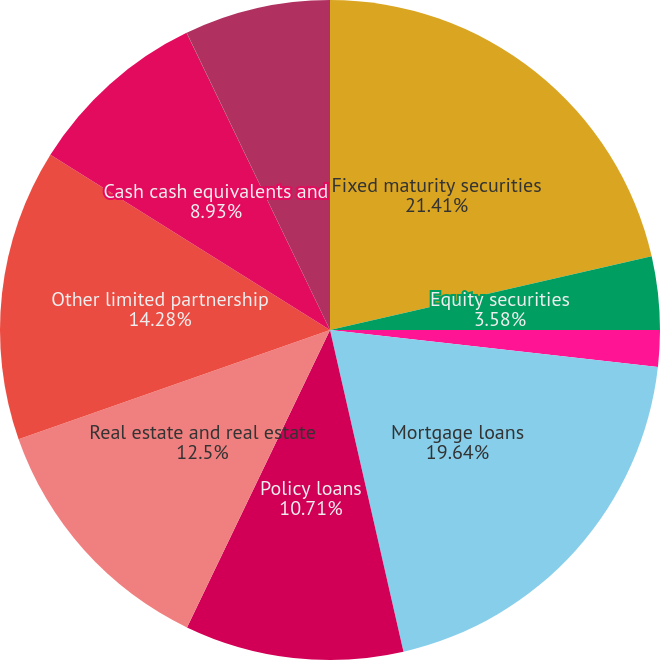Convert chart. <chart><loc_0><loc_0><loc_500><loc_500><pie_chart><fcel>Fixed maturity securities<fcel>Equity securities<fcel>FVO and trading securities<fcel>Mortgage loans<fcel>Policy loans<fcel>Real estate and real estate<fcel>Other limited partnership<fcel>Cash cash equivalents and<fcel>Operating joint ventures<fcel>Other<nl><fcel>21.42%<fcel>3.58%<fcel>1.79%<fcel>19.64%<fcel>10.71%<fcel>12.5%<fcel>14.28%<fcel>8.93%<fcel>0.01%<fcel>7.15%<nl></chart> 